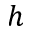<formula> <loc_0><loc_0><loc_500><loc_500>h</formula> 